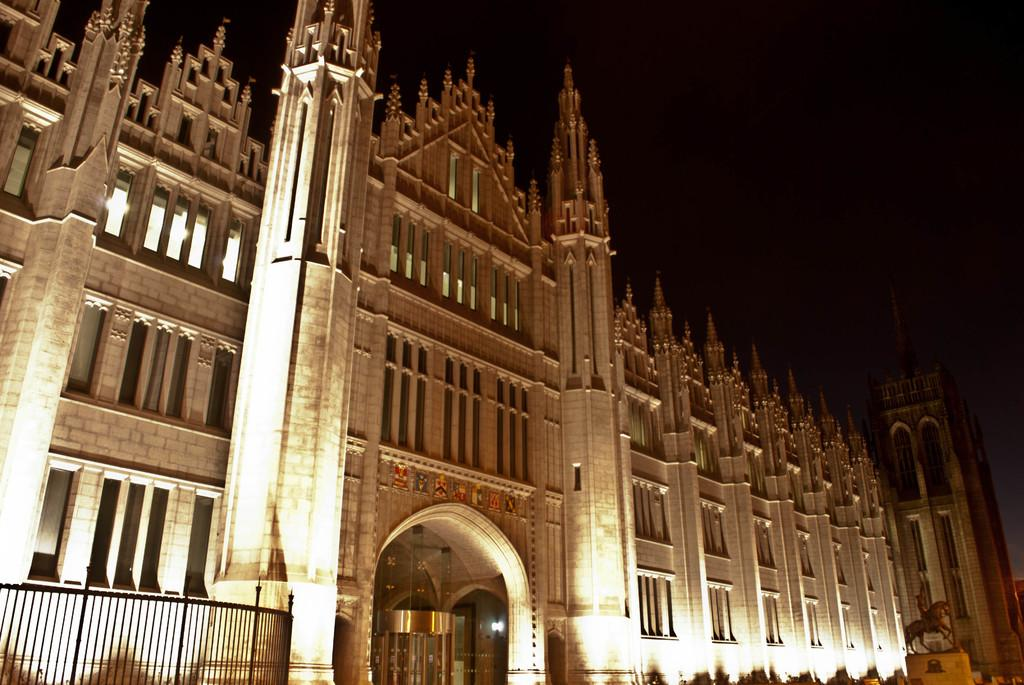What is the main structure visible in the image? There is a building in the image. What can be seen on the left side of the image? There is a railing on the left side of the image. How would you describe the sky in the background of the image? The sky in the background is completely dark. Can you see a rose growing near the building in the image? There is no rose visible in the image. 